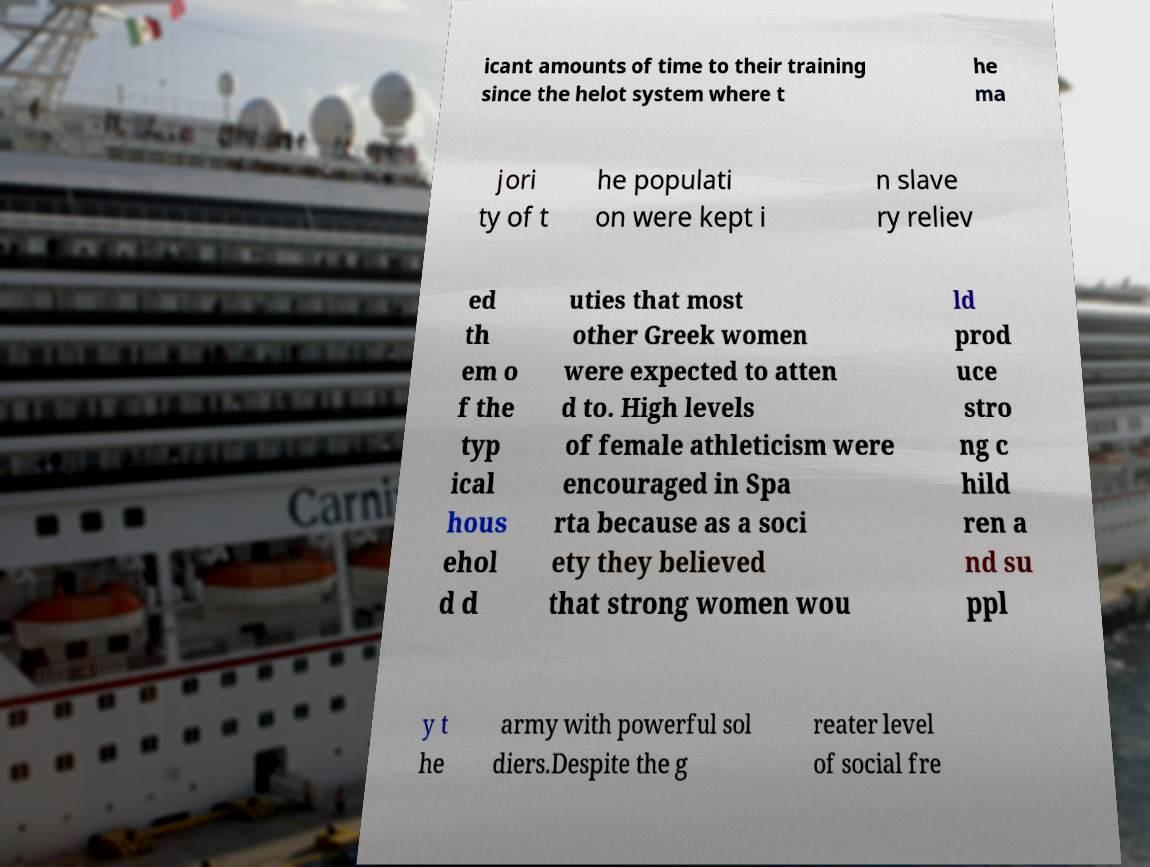Please read and relay the text visible in this image. What does it say? icant amounts of time to their training since the helot system where t he ma jori ty of t he populati on were kept i n slave ry reliev ed th em o f the typ ical hous ehol d d uties that most other Greek women were expected to atten d to. High levels of female athleticism were encouraged in Spa rta because as a soci ety they believed that strong women wou ld prod uce stro ng c hild ren a nd su ppl y t he army with powerful sol diers.Despite the g reater level of social fre 